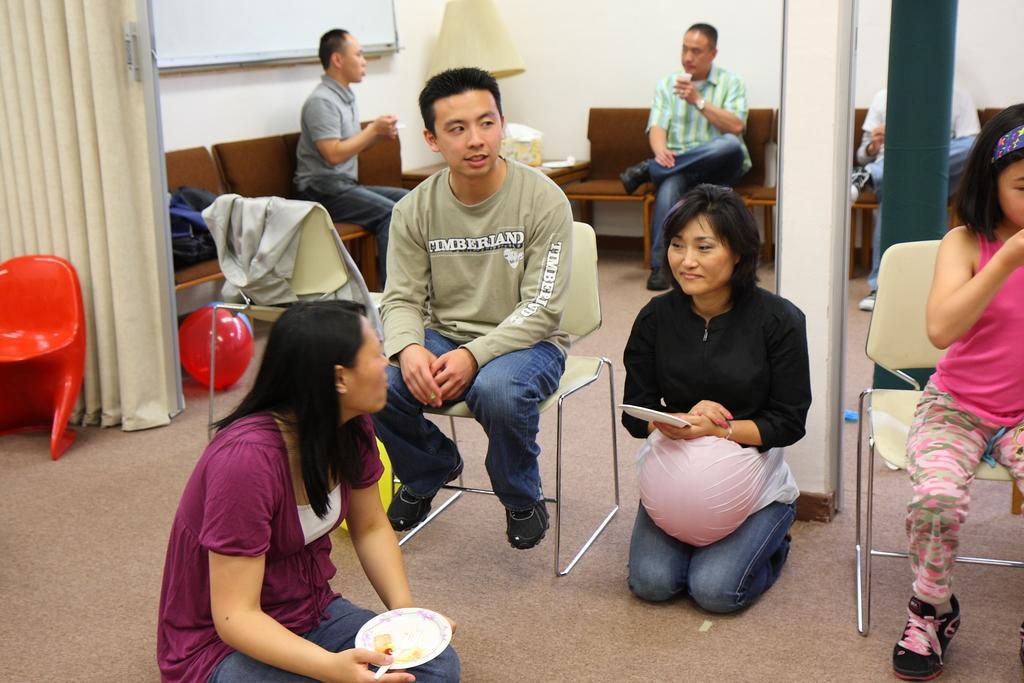In one or two sentences, can you explain what this image depicts? In this image we can see some people sitting on the chairs and some are sitting on the floor. In the background there are curtains, board attached to the wall, table lamp on a side table and balloons on the floor. 